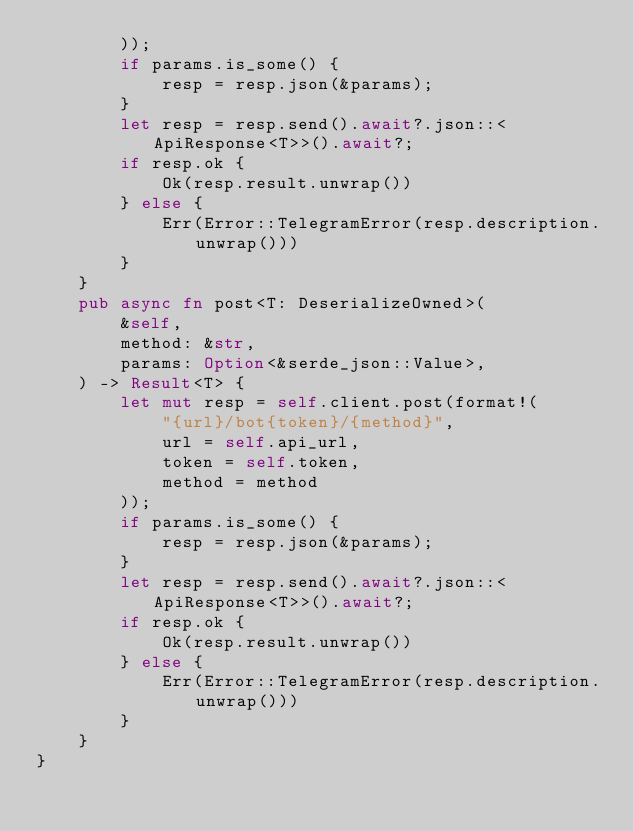Convert code to text. <code><loc_0><loc_0><loc_500><loc_500><_Rust_>        ));
        if params.is_some() {
            resp = resp.json(&params);
        }
        let resp = resp.send().await?.json::<ApiResponse<T>>().await?;
        if resp.ok {
            Ok(resp.result.unwrap())
        } else {
            Err(Error::TelegramError(resp.description.unwrap()))
        }
    }
    pub async fn post<T: DeserializeOwned>(
        &self,
        method: &str,
        params: Option<&serde_json::Value>,
    ) -> Result<T> {
        let mut resp = self.client.post(format!(
            "{url}/bot{token}/{method}",
            url = self.api_url,
            token = self.token,
            method = method
        ));
        if params.is_some() {
            resp = resp.json(&params);
        }
        let resp = resp.send().await?.json::<ApiResponse<T>>().await?;
        if resp.ok {
            Ok(resp.result.unwrap())
        } else {
            Err(Error::TelegramError(resp.description.unwrap()))
        }
    }
}
</code> 